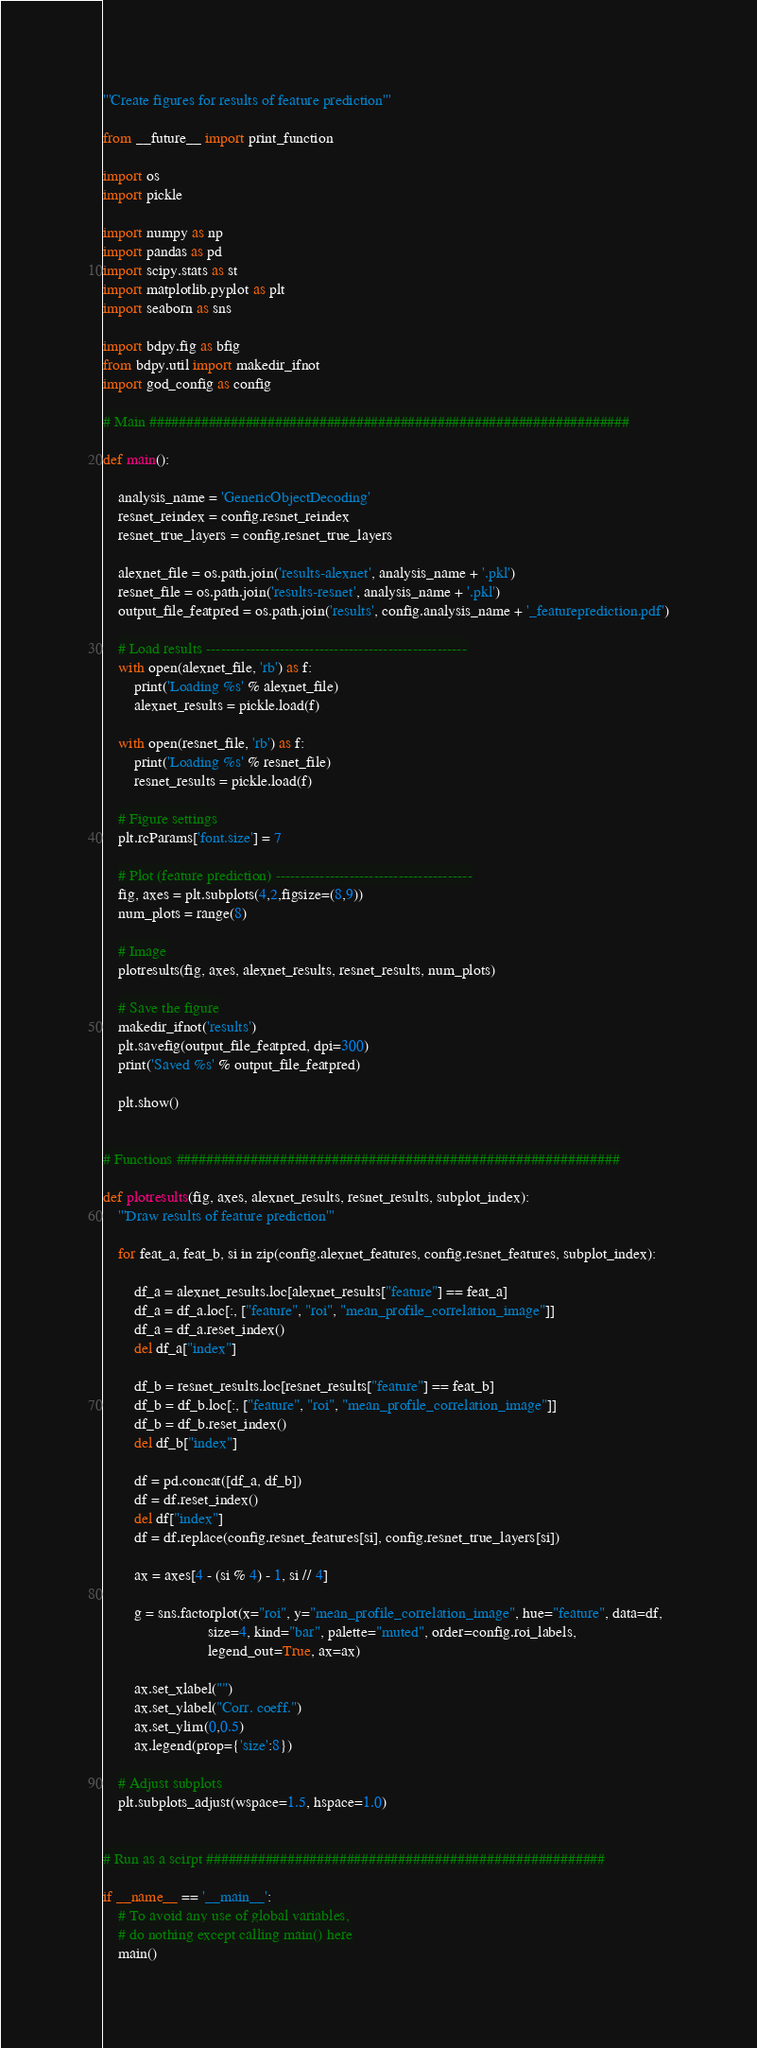Convert code to text. <code><loc_0><loc_0><loc_500><loc_500><_Python_>'''Create figures for results of feature prediction'''

from __future__ import print_function

import os
import pickle

import numpy as np
import pandas as pd
import scipy.stats as st
import matplotlib.pyplot as plt
import seaborn as sns

import bdpy.fig as bfig
from bdpy.util import makedir_ifnot
import god_config as config

# Main #################################################################

def main():

    analysis_name = 'GenericObjectDecoding'
    resnet_reindex = config.resnet_reindex
    resnet_true_layers = config.resnet_true_layers

    alexnet_file = os.path.join('results-alexnet', analysis_name + '.pkl')
    resnet_file = os.path.join('results-resnet', analysis_name + '.pkl')
    output_file_featpred = os.path.join('results', config.analysis_name + '_featureprediction.pdf')

    # Load results -----------------------------------------------------
    with open(alexnet_file, 'rb') as f:
        print('Loading %s' % alexnet_file)
        alexnet_results = pickle.load(f)

    with open(resnet_file, 'rb') as f:
        print('Loading %s' % resnet_file)
        resnet_results = pickle.load(f)

    # Figure settings
    plt.rcParams['font.size'] = 7

    # Plot (feature prediction) ----------------------------------------
    fig, axes = plt.subplots(4,2,figsize=(8,9))
    num_plots = range(8)

    # Image
    plotresults(fig, axes, alexnet_results, resnet_results, num_plots)

    # Save the figure
    makedir_ifnot('results')
    plt.savefig(output_file_featpred, dpi=300)
    print('Saved %s' % output_file_featpred)

    plt.show()


# Functions ############################################################

def plotresults(fig, axes, alexnet_results, resnet_results, subplot_index):
    '''Draw results of feature prediction'''

    for feat_a, feat_b, si in zip(config.alexnet_features, config.resnet_features, subplot_index):

        df_a = alexnet_results.loc[alexnet_results["feature"] == feat_a]
        df_a = df_a.loc[:, ["feature", "roi", "mean_profile_correlation_image"]]
        df_a = df_a.reset_index()
        del df_a["index"]

        df_b = resnet_results.loc[resnet_results["feature"] == feat_b]
        df_b = df_b.loc[:, ["feature", "roi", "mean_profile_correlation_image"]]
        df_b = df_b.reset_index()
        del df_b["index"]

        df = pd.concat([df_a, df_b])
        df = df.reset_index()
        del df["index"]
        df = df.replace(config.resnet_features[si], config.resnet_true_layers[si])

        ax = axes[4 - (si % 4) - 1, si // 4]

        g = sns.factorplot(x="roi", y="mean_profile_correlation_image", hue="feature", data=df,
                           size=4, kind="bar", palette="muted", order=config.roi_labels,
                           legend_out=True, ax=ax)

        ax.set_xlabel("")
        ax.set_ylabel("Corr. coeff.")
        ax.set_ylim(0,0.5)
        ax.legend(prop={'size':8})

    # Adjust subplots
    plt.subplots_adjust(wspace=1.5, hspace=1.0)


# Run as a scirpt ######################################################

if __name__ == '__main__':
    # To avoid any use of global variables,
    # do nothing except calling main() here
    main()
</code> 